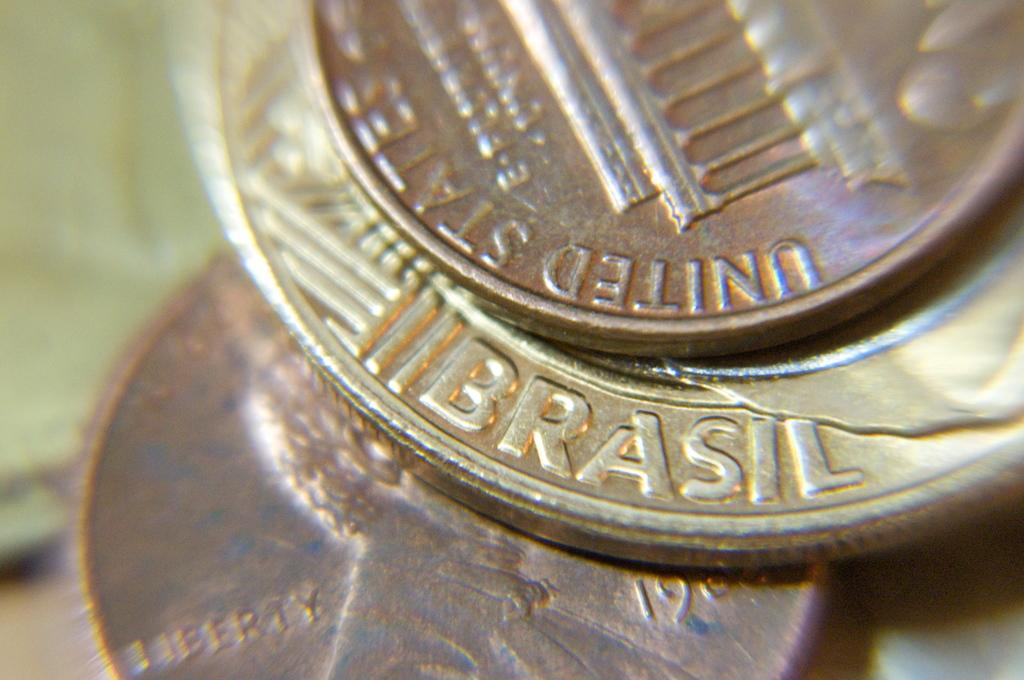<image>
Present a compact description of the photo's key features. A United States penny sits on top of a coin from "Brasil". 